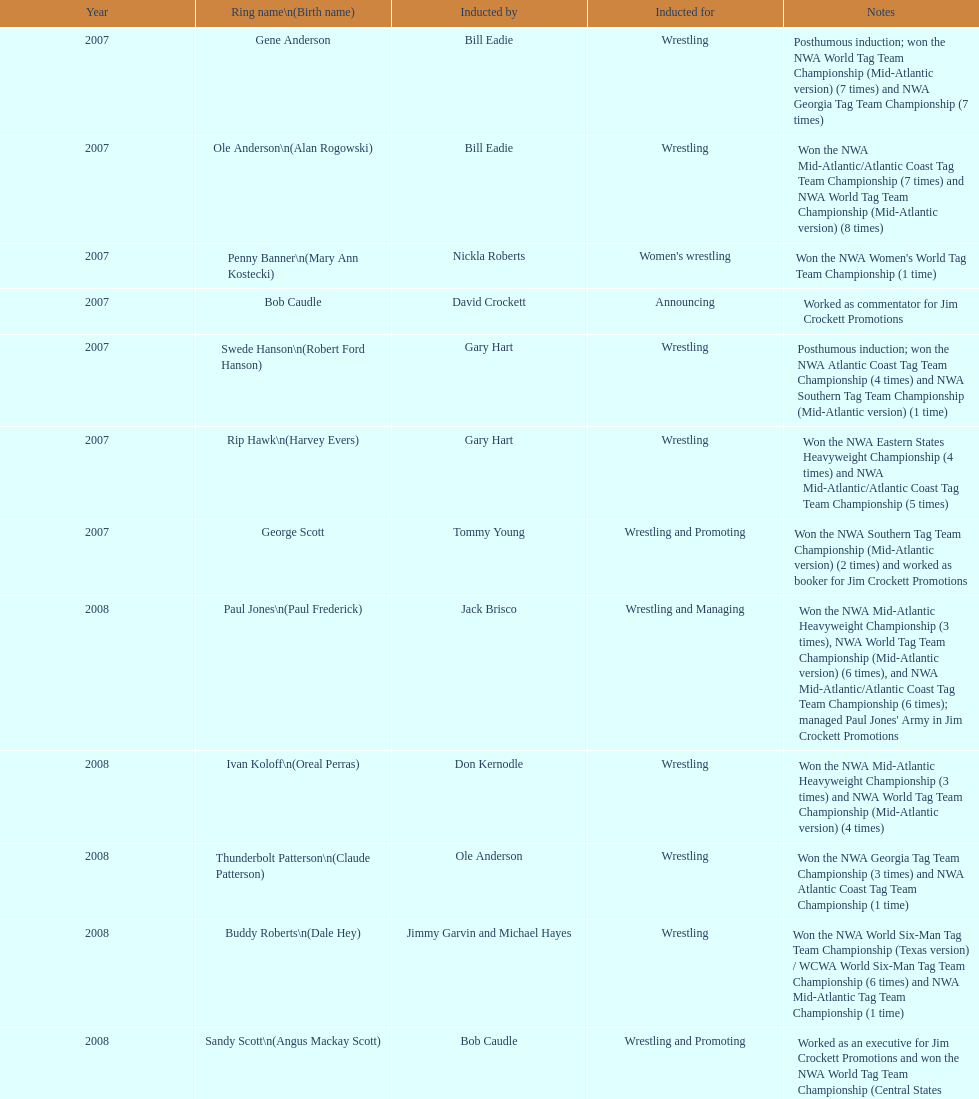Who was admitted following royal? Lance Russell. 